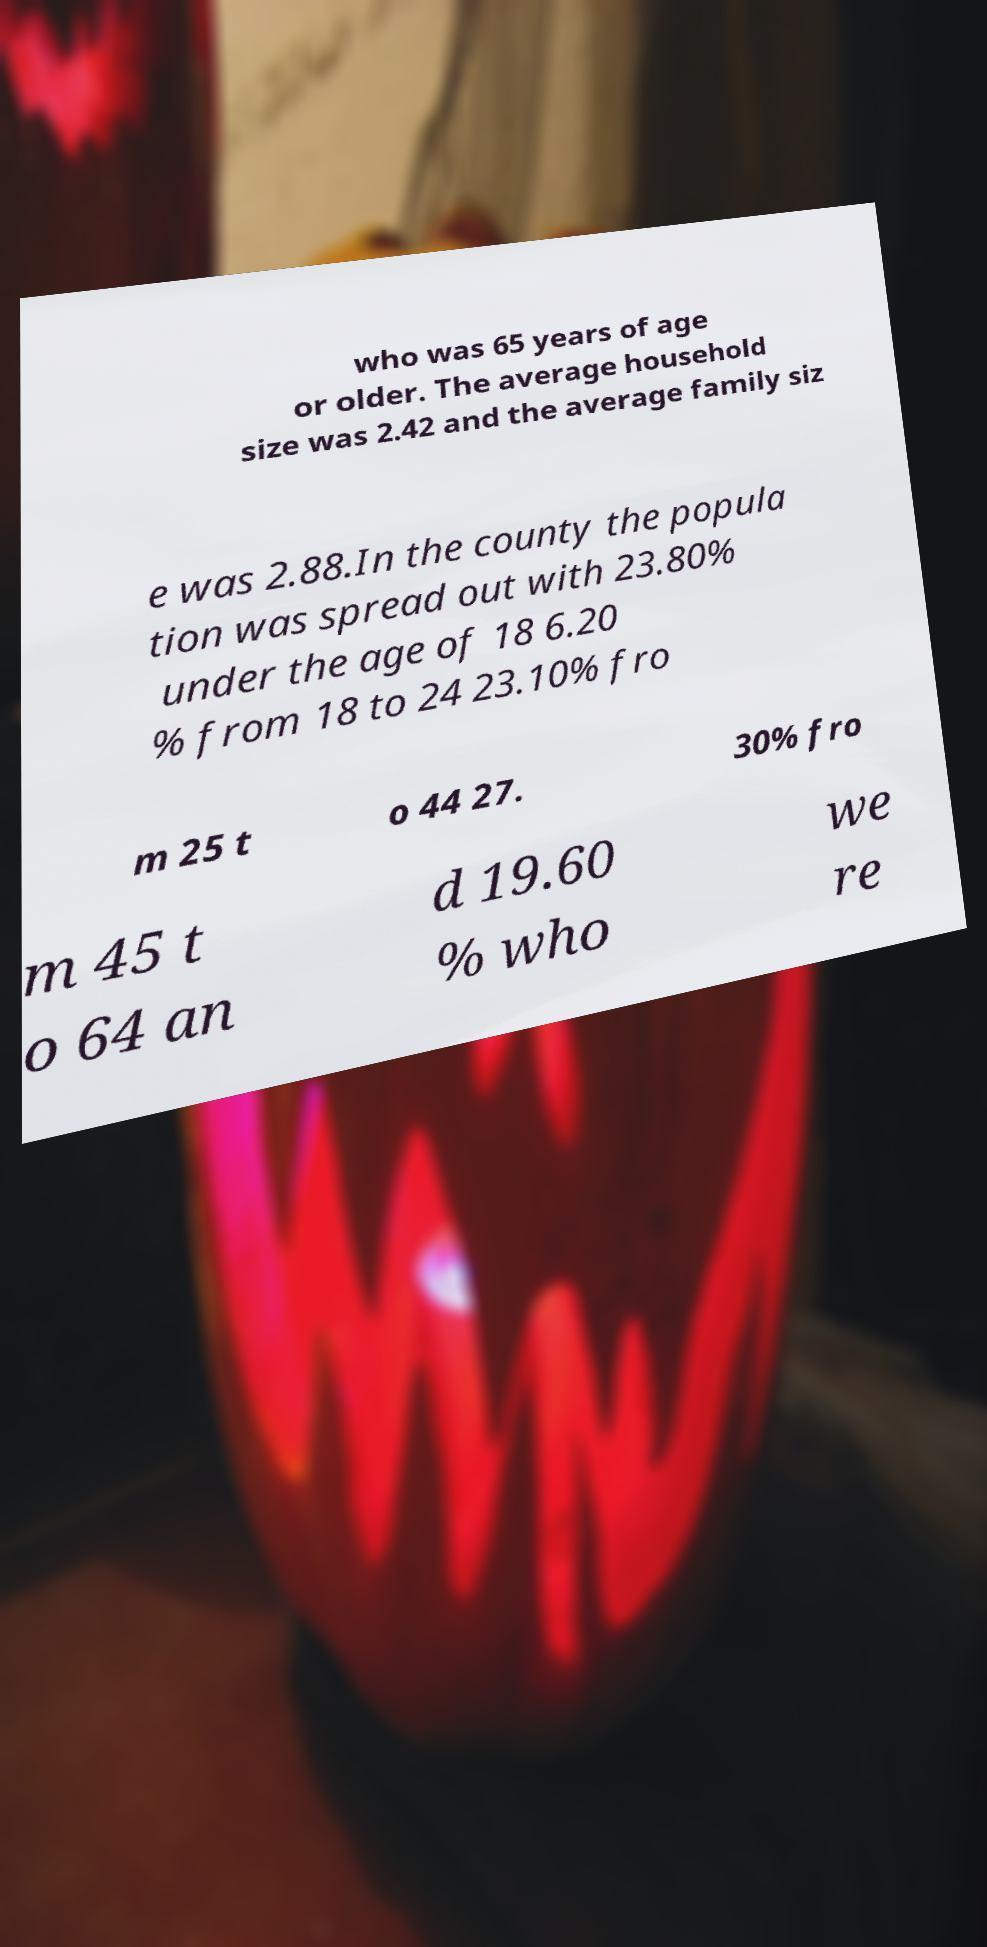What messages or text are displayed in this image? I need them in a readable, typed format. who was 65 years of age or older. The average household size was 2.42 and the average family siz e was 2.88.In the county the popula tion was spread out with 23.80% under the age of 18 6.20 % from 18 to 24 23.10% fro m 25 t o 44 27. 30% fro m 45 t o 64 an d 19.60 % who we re 